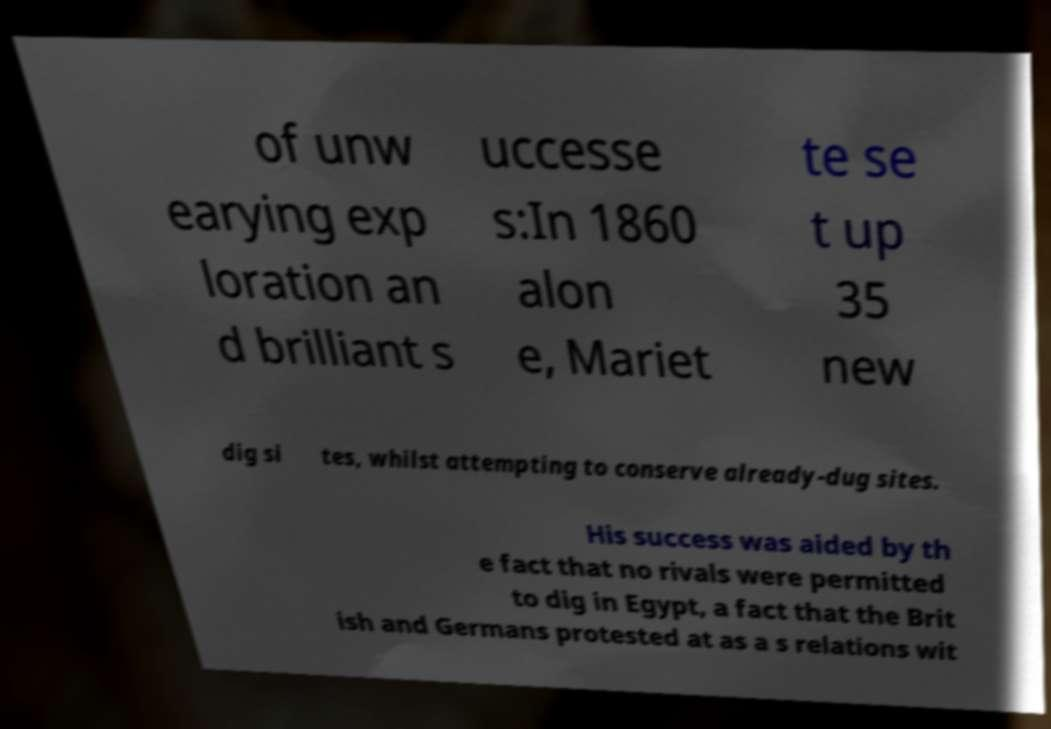What messages or text are displayed in this image? I need them in a readable, typed format. of unw earying exp loration an d brilliant s uccesse s:In 1860 alon e, Mariet te se t up 35 new dig si tes, whilst attempting to conserve already-dug sites. His success was aided by th e fact that no rivals were permitted to dig in Egypt, a fact that the Brit ish and Germans protested at as a s relations wit 